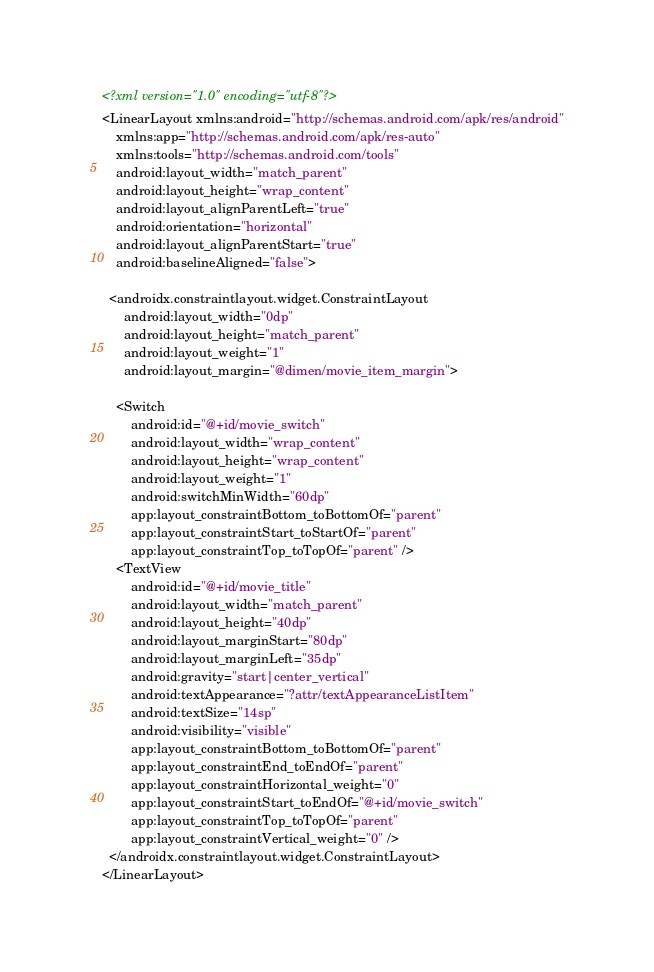Convert code to text. <code><loc_0><loc_0><loc_500><loc_500><_XML_><?xml version="1.0" encoding="utf-8"?>
<LinearLayout xmlns:android="http://schemas.android.com/apk/res/android"
    xmlns:app="http://schemas.android.com/apk/res-auto"
    xmlns:tools="http://schemas.android.com/tools"
    android:layout_width="match_parent"
    android:layout_height="wrap_content"
    android:layout_alignParentLeft="true"
    android:orientation="horizontal"
    android:layout_alignParentStart="true"
    android:baselineAligned="false">

  <androidx.constraintlayout.widget.ConstraintLayout
      android:layout_width="0dp"
      android:layout_height="match_parent"
      android:layout_weight="1"
      android:layout_margin="@dimen/movie_item_margin">

    <Switch
        android:id="@+id/movie_switch"
        android:layout_width="wrap_content"
        android:layout_height="wrap_content"
        android:layout_weight="1"
        android:switchMinWidth="60dp"
        app:layout_constraintBottom_toBottomOf="parent"
        app:layout_constraintStart_toStartOf="parent"
        app:layout_constraintTop_toTopOf="parent" />
    <TextView
        android:id="@+id/movie_title"
        android:layout_width="match_parent"
        android:layout_height="40dp"
        android:layout_marginStart="80dp"
        android:layout_marginLeft="35dp"
        android:gravity="start|center_vertical"
        android:textAppearance="?attr/textAppearanceListItem"
        android:textSize="14sp"
        android:visibility="visible"
        app:layout_constraintBottom_toBottomOf="parent"
        app:layout_constraintEnd_toEndOf="parent"
        app:layout_constraintHorizontal_weight="0"
        app:layout_constraintStart_toEndOf="@+id/movie_switch"
        app:layout_constraintTop_toTopOf="parent"
        app:layout_constraintVertical_weight="0" />
  </androidx.constraintlayout.widget.ConstraintLayout>
</LinearLayout>
</code> 